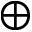<formula> <loc_0><loc_0><loc_500><loc_500>\oplus</formula> 